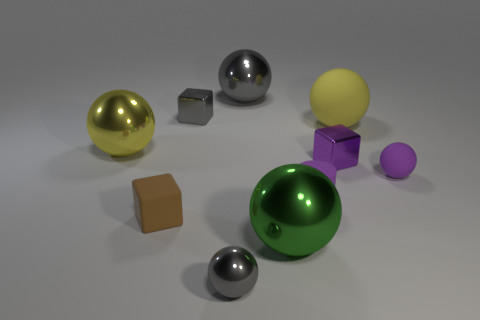There is another big matte thing that is the same shape as the large green thing; what color is it?
Your response must be concise. Yellow. What number of objects are things that are left of the tiny gray metallic sphere or metal objects that are in front of the green shiny object?
Offer a terse response. 4. What shape is the tiny brown rubber thing?
Your response must be concise. Cube. There is a metal thing that is the same color as the matte cylinder; what shape is it?
Ensure brevity in your answer.  Cube. What number of small cubes are made of the same material as the green sphere?
Make the answer very short. 2. The cylinder has what color?
Your answer should be very brief. Purple. There is a matte cylinder that is the same size as the purple metallic cube; what is its color?
Offer a terse response. Purple. Is there a tiny sphere of the same color as the cylinder?
Make the answer very short. Yes. Does the large yellow object to the right of the tiny rubber block have the same shape as the large thing in front of the purple cylinder?
Offer a very short reply. Yes. There is a matte sphere that is the same color as the small rubber cylinder; what is its size?
Keep it short and to the point. Small. 